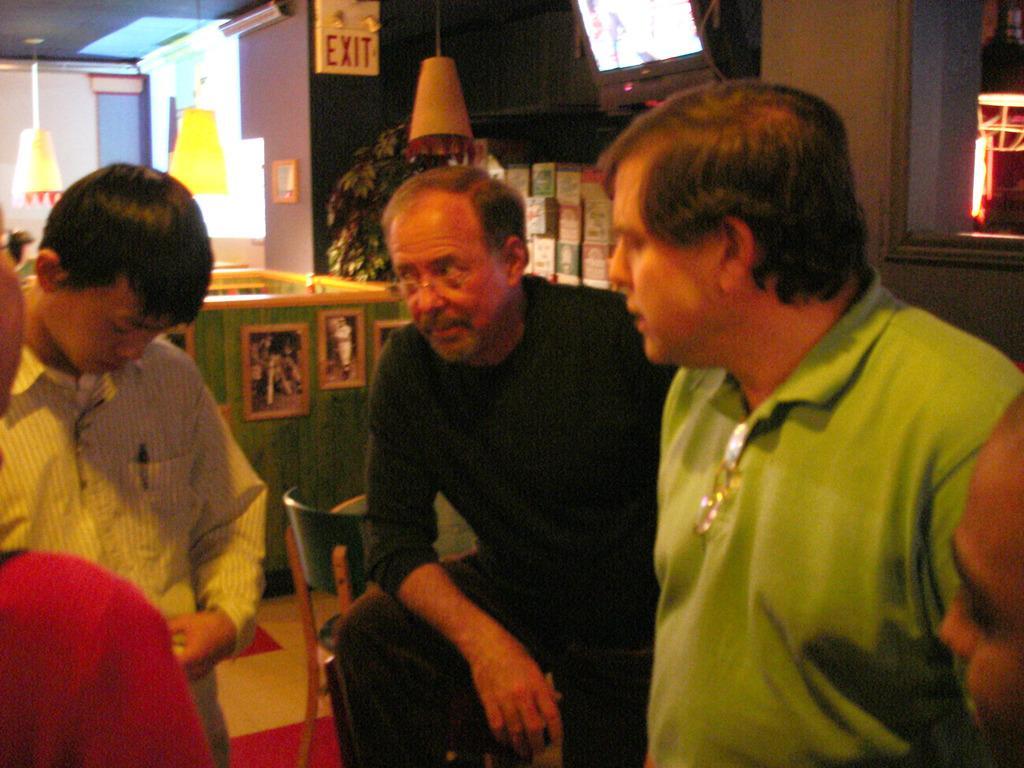How would you summarize this image in a sentence or two? In this picture we can see four people standing on the floor, chair, frames on the wall and in the background we can see a tree. 